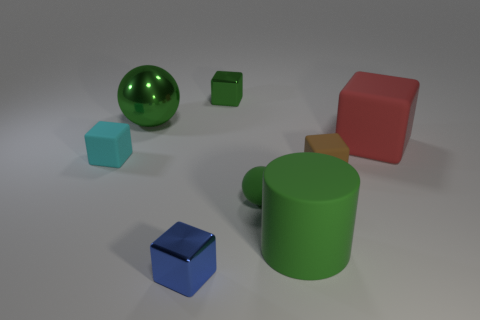What shape is the big object that is the same color as the large shiny ball?
Your answer should be compact. Cylinder. How many red objects are either large cubes or large rubber balls?
Give a very brief answer. 1. The cyan thing has what size?
Your answer should be compact. Small. Is the number of tiny things on the left side of the large rubber cylinder greater than the number of tiny green spheres?
Give a very brief answer. Yes. How many matte objects are to the left of the big green rubber object?
Your answer should be compact. 2. Are there any gray things that have the same size as the green matte cylinder?
Offer a terse response. No. There is another large thing that is the same shape as the blue object; what is its color?
Provide a short and direct response. Red. Do the object on the left side of the big green metal ball and the green rubber object that is on the left side of the matte cylinder have the same size?
Provide a succinct answer. Yes. Are there any other large objects of the same shape as the red rubber thing?
Your answer should be very brief. No. Is the number of matte objects to the left of the shiny sphere the same as the number of large gray spheres?
Make the answer very short. No. 